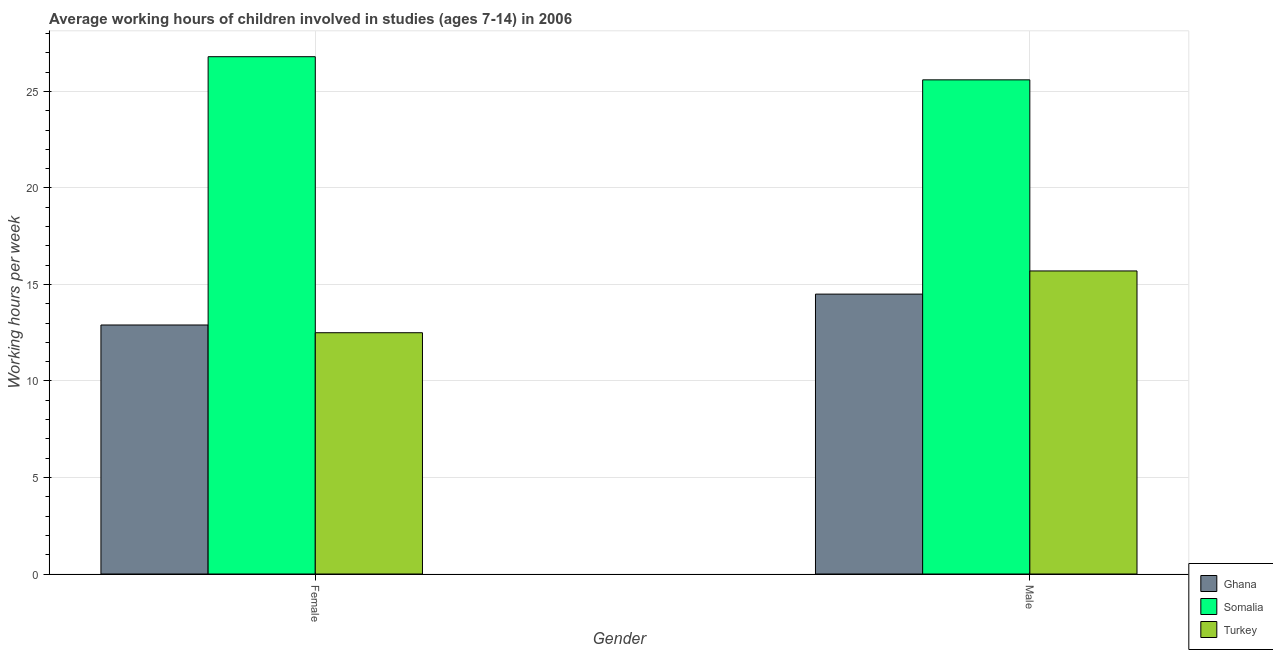How many groups of bars are there?
Your response must be concise. 2. Are the number of bars on each tick of the X-axis equal?
Provide a succinct answer. Yes. How many bars are there on the 2nd tick from the left?
Ensure brevity in your answer.  3. What is the average working hour of male children in Ghana?
Ensure brevity in your answer.  14.5. Across all countries, what is the maximum average working hour of male children?
Your response must be concise. 25.6. Across all countries, what is the minimum average working hour of male children?
Keep it short and to the point. 14.5. In which country was the average working hour of female children maximum?
Offer a very short reply. Somalia. In which country was the average working hour of female children minimum?
Your answer should be compact. Turkey. What is the total average working hour of female children in the graph?
Your answer should be very brief. 52.2. What is the difference between the average working hour of male children in Ghana and that in Turkey?
Give a very brief answer. -1.2. What is the difference between the average working hour of female children in Turkey and the average working hour of male children in Somalia?
Provide a short and direct response. -13.1. What is the average average working hour of male children per country?
Keep it short and to the point. 18.6. What is the difference between the average working hour of female children and average working hour of male children in Somalia?
Ensure brevity in your answer.  1.2. In how many countries, is the average working hour of male children greater than 22 hours?
Give a very brief answer. 1. What is the ratio of the average working hour of male children in Ghana to that in Turkey?
Your answer should be compact. 0.92. What does the 2nd bar from the left in Male represents?
Provide a short and direct response. Somalia. What does the 2nd bar from the right in Female represents?
Offer a terse response. Somalia. How many countries are there in the graph?
Your response must be concise. 3. How are the legend labels stacked?
Offer a terse response. Vertical. What is the title of the graph?
Your answer should be compact. Average working hours of children involved in studies (ages 7-14) in 2006. Does "Congo (Democratic)" appear as one of the legend labels in the graph?
Offer a terse response. No. What is the label or title of the Y-axis?
Provide a short and direct response. Working hours per week. What is the Working hours per week of Somalia in Female?
Ensure brevity in your answer.  26.8. What is the Working hours per week of Turkey in Female?
Offer a terse response. 12.5. What is the Working hours per week of Somalia in Male?
Your answer should be compact. 25.6. Across all Gender, what is the maximum Working hours per week in Somalia?
Ensure brevity in your answer.  26.8. Across all Gender, what is the minimum Working hours per week of Somalia?
Your response must be concise. 25.6. What is the total Working hours per week of Ghana in the graph?
Make the answer very short. 27.4. What is the total Working hours per week of Somalia in the graph?
Provide a short and direct response. 52.4. What is the total Working hours per week in Turkey in the graph?
Your answer should be very brief. 28.2. What is the difference between the Working hours per week of Turkey in Female and that in Male?
Keep it short and to the point. -3.2. What is the difference between the Working hours per week of Ghana in Female and the Working hours per week of Somalia in Male?
Offer a terse response. -12.7. What is the difference between the Working hours per week of Ghana in Female and the Working hours per week of Turkey in Male?
Offer a very short reply. -2.8. What is the average Working hours per week in Ghana per Gender?
Your answer should be very brief. 13.7. What is the average Working hours per week of Somalia per Gender?
Offer a terse response. 26.2. What is the average Working hours per week of Turkey per Gender?
Your response must be concise. 14.1. What is the difference between the Working hours per week of Somalia and Working hours per week of Turkey in Female?
Your answer should be very brief. 14.3. What is the difference between the Working hours per week of Ghana and Working hours per week of Somalia in Male?
Your answer should be very brief. -11.1. What is the difference between the Working hours per week of Ghana and Working hours per week of Turkey in Male?
Give a very brief answer. -1.2. What is the ratio of the Working hours per week of Ghana in Female to that in Male?
Keep it short and to the point. 0.89. What is the ratio of the Working hours per week in Somalia in Female to that in Male?
Your response must be concise. 1.05. What is the ratio of the Working hours per week of Turkey in Female to that in Male?
Give a very brief answer. 0.8. What is the difference between the highest and the second highest Working hours per week in Ghana?
Ensure brevity in your answer.  1.6. What is the difference between the highest and the second highest Working hours per week in Somalia?
Give a very brief answer. 1.2. 